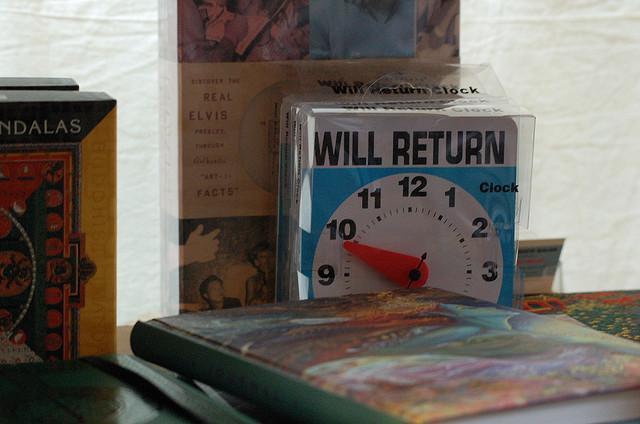How many books are in the picture?
Give a very brief answer. 3. How many suv cars are in the picture?
Give a very brief answer. 0. 